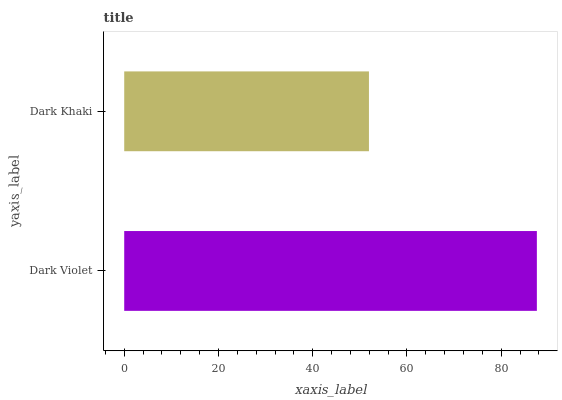Is Dark Khaki the minimum?
Answer yes or no. Yes. Is Dark Violet the maximum?
Answer yes or no. Yes. Is Dark Khaki the maximum?
Answer yes or no. No. Is Dark Violet greater than Dark Khaki?
Answer yes or no. Yes. Is Dark Khaki less than Dark Violet?
Answer yes or no. Yes. Is Dark Khaki greater than Dark Violet?
Answer yes or no. No. Is Dark Violet less than Dark Khaki?
Answer yes or no. No. Is Dark Violet the high median?
Answer yes or no. Yes. Is Dark Khaki the low median?
Answer yes or no. Yes. Is Dark Khaki the high median?
Answer yes or no. No. Is Dark Violet the low median?
Answer yes or no. No. 